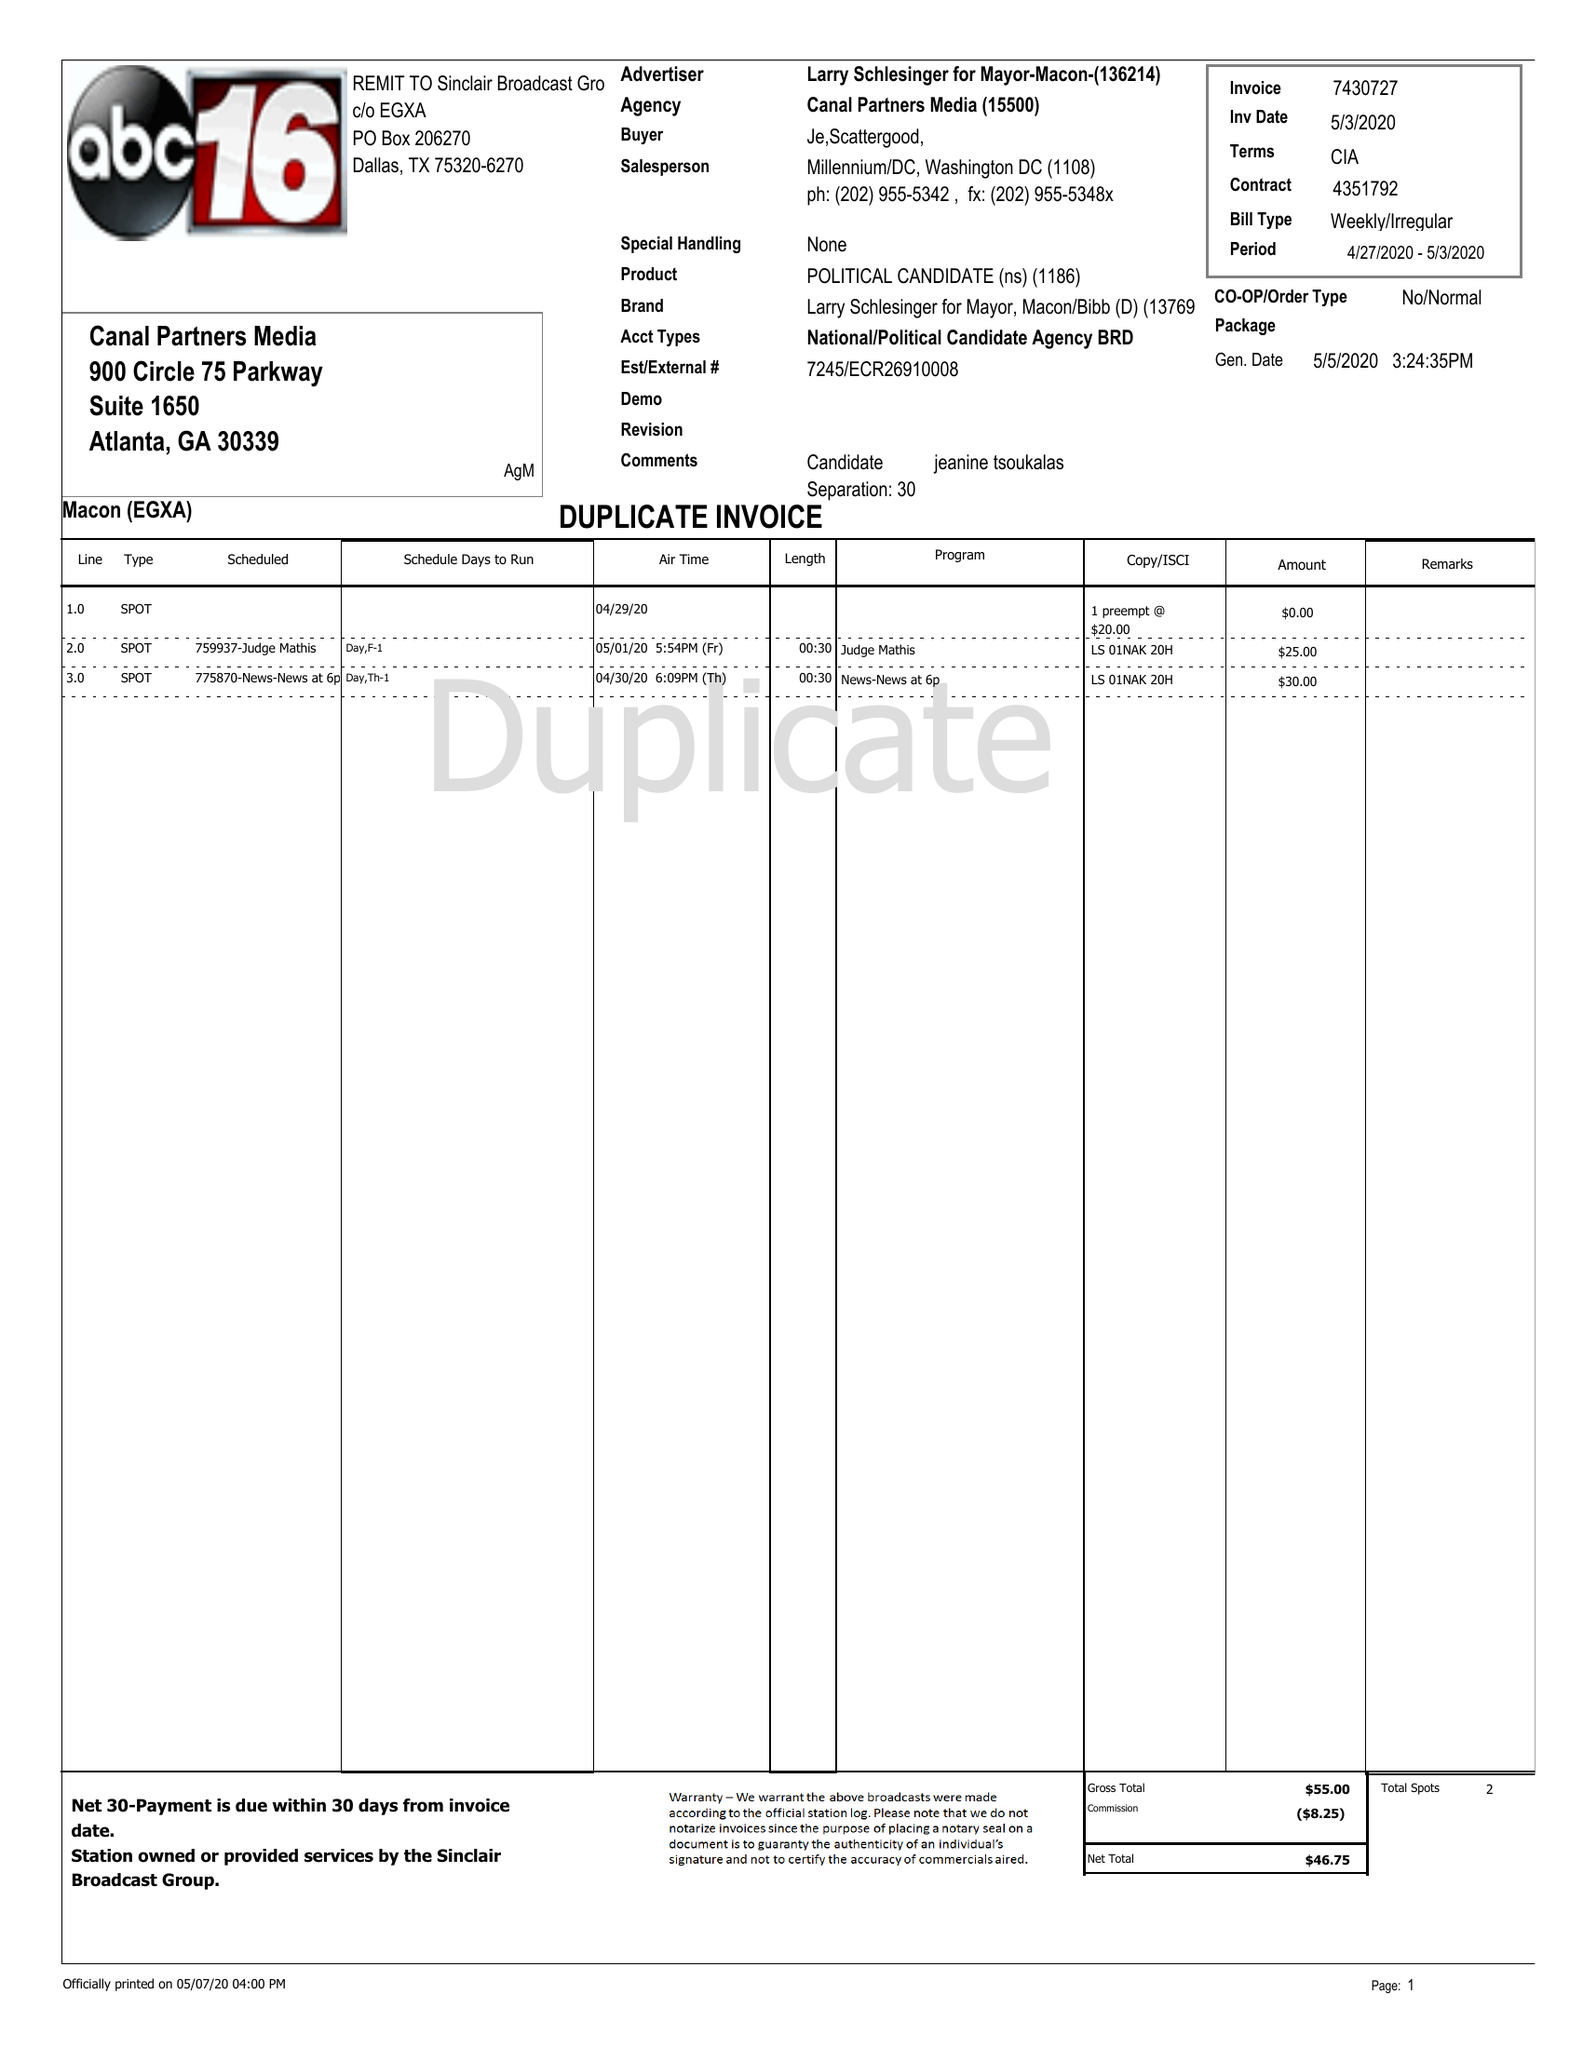What is the value for the contract_num?
Answer the question using a single word or phrase. 4351792 